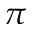Convert formula to latex. <formula><loc_0><loc_0><loc_500><loc_500>\pi</formula> 